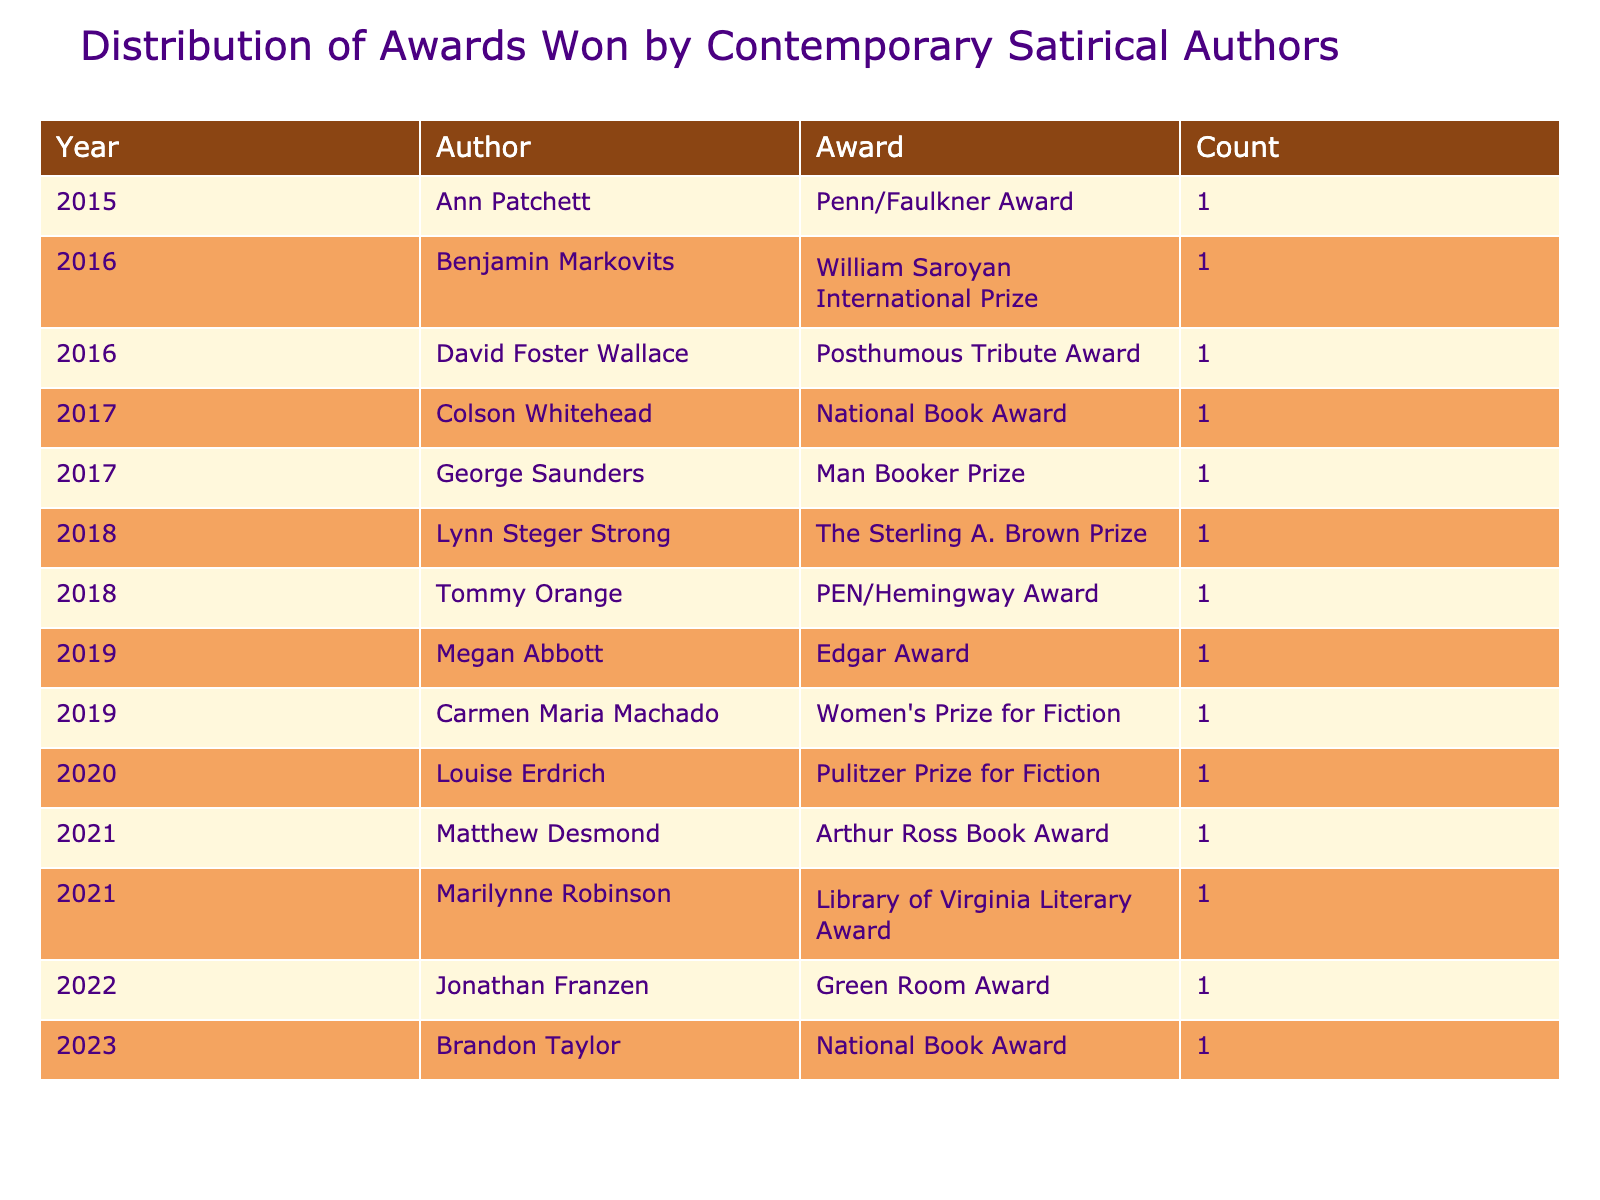What award did Colson Whitehead win? Colson Whitehead won the National Book Award in 2017, as listed in the table under the year 2017 in the award column.
Answer: National Book Award How many authors won awards in 2021? In 2021, two authors are listed: Matthew Desmond with the Arthur Ross Book Award and Marilynne Robinson with the Library of Virginia Literary Award. Therefore, the count is 2.
Answer: 2 Which year had the most distinct authors winning awards? Each year listed has one author winning an award, with no duplications in authors or awards. Since there are distinct authors each year, and all years (2015 to 2023) have one author, it can be concluded that every year has the same number of distinct authors: 1.
Answer: 1 Did any authors win awards in 2019? Yes, two authors won awards in 2019: Megan Abbott won the Edgar Award, and Carmen Maria Machado won the Women's Prize for Fiction, as evidenced in the table.
Answer: Yes What is the total number of awards won from 2015 to 2023? Counting all the entries in the table from 2015 to 2023, each year shows a single award won by a distinct author. Since there are nine entries in total, the total number of awards won is simply 9.
Answer: 9 Which author received a posthumous tribute? The only author listed as receiving a posthumous tribute award is David Foster Wallace in 2016, as stated in the table under the corresponding year and award column.
Answer: David Foster Wallace How many different awards were given out from 2015 to 2023? There are eight different awards listed in the table, one for each unique award corresponding to the authors from different years. The distinct awards are: Penn/Faulkner Award, William Saroyan International Prize, Posthumous Tribute Award, National Book Award, Man Booker Prize, The Sterling A. Brown Prize, PEN/Hemingway Award, Pulitzer Prize for Fiction, Arthur Ross Book Award, Library of Virginia Literary Award, Green Room Award, and Women's Prize for Fiction. Since the following years also have unique awards, we count them all to get 11 awards.
Answer: 11 Which author won the most recent award? The most recent year in the table is 2023, where Brandon Taylor won the National Book Award. Therefore, Brandon Taylor is the author who won the latest award as per the data presented.
Answer: Brandon Taylor What is the average year of the awards listed? To find the average year, add together all the years from 2015 to 2023: (2015 + 2016 + 2017 + 2018 + 2019 + 2020 + 2021 + 2022 + 2023) = 18200, and divide by the number of awards, which is 9: 18200 / 9 = 2022.22 gives an approximate average year of 2022.
Answer: 2022 